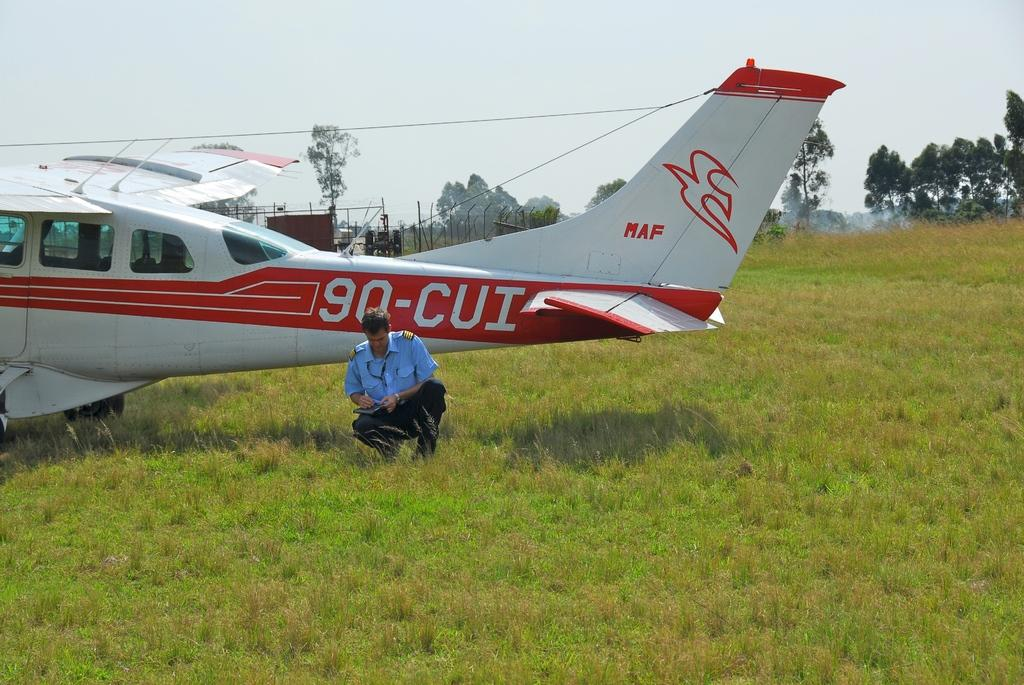<image>
Relay a brief, clear account of the picture shown. A man in a pilot uniform squatting in the grass next to the red and white small aircraft 90-CUI. 